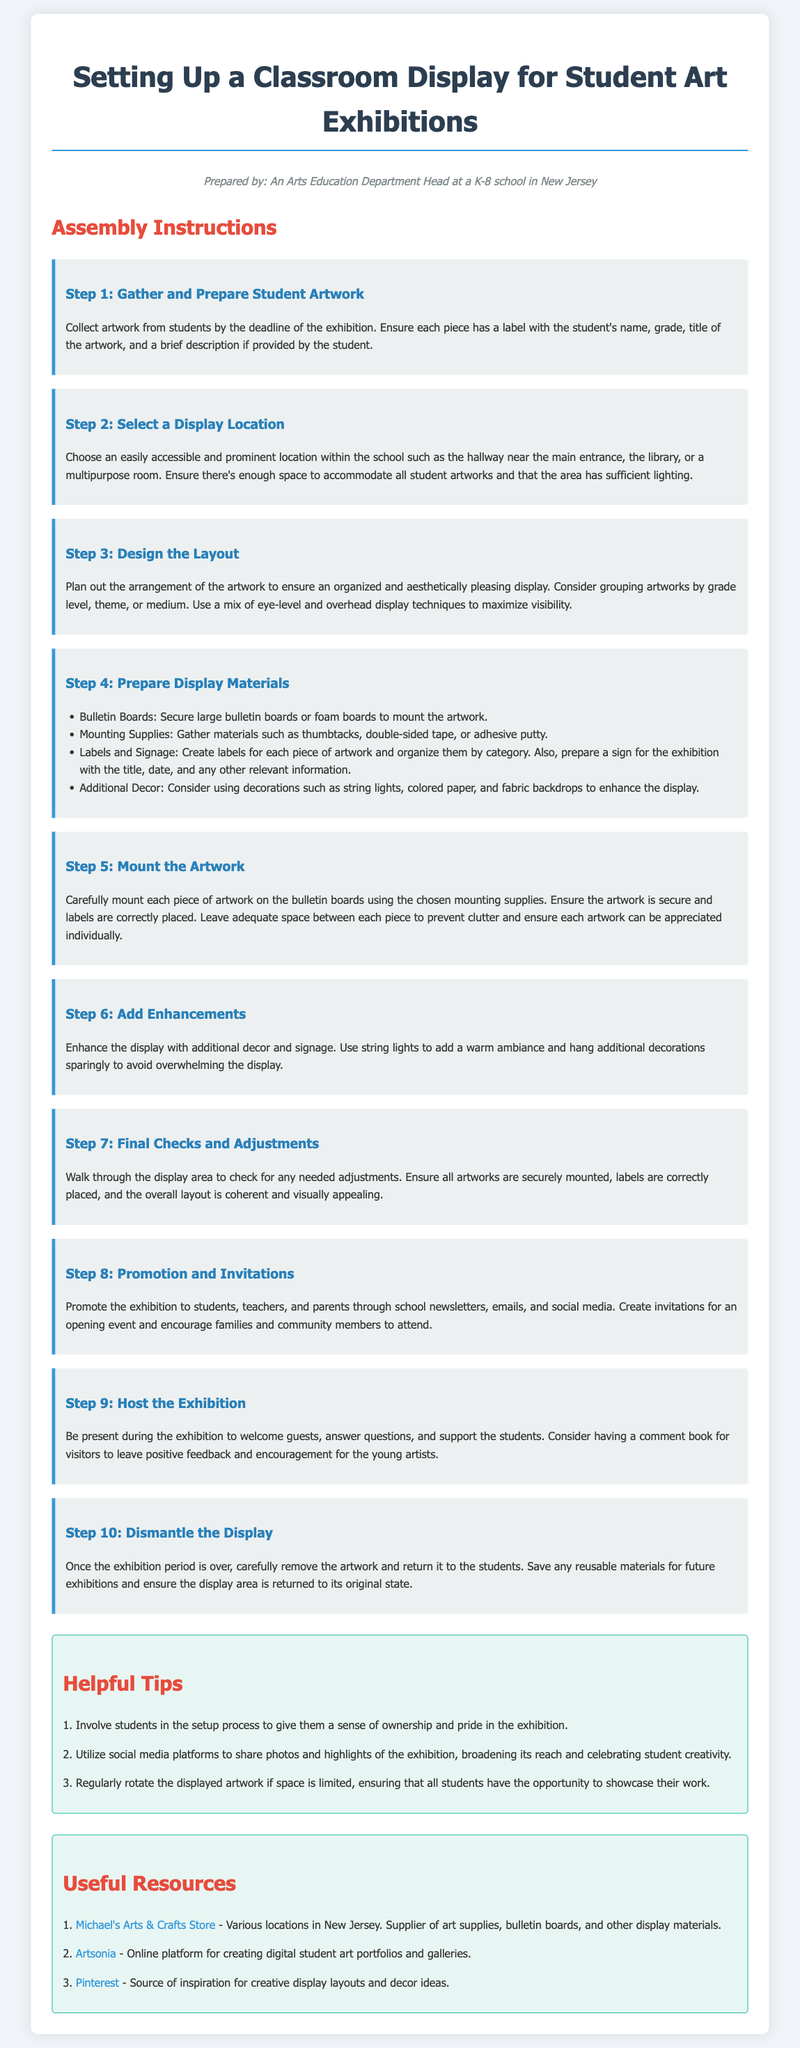What is the first step in the display setup? The first step involves collecting artwork from students and ensuring it is properly labeled.
Answer: Gather and Prepare Student Artwork Where should the display be located? The location should be easily accessible and prominent within the school.
Answer: Prominent location What materials are needed for mounting the artwork? The document lists thumbtacks, double-sided tape, or adhesive putty as mounting supplies.
Answer: Mounting Supplies How many tips are provided in the Helpful Tips section? The document provides a total of three helpful tips for setting up the exhibition.
Answer: Three tips What is the purpose of the comment book during the exhibition? The comment book is intended for visitors to leave feedback and encouragement for the young artists.
Answer: Visitor feedback Which online platform is mentioned as a resource for digital student art portfolios? Artsonia is specifically mentioned as the online platform for digital portfolios.
Answer: Artsonia Why is it suggested to involve students in the setup process? Involving students gives them a sense of ownership and pride in the exhibition.
Answer: Sense of ownership What should be done after the exhibition period is over? After the exhibition, the artwork should be carefully removed and returned to the students.
Answer: Return artwork to students 